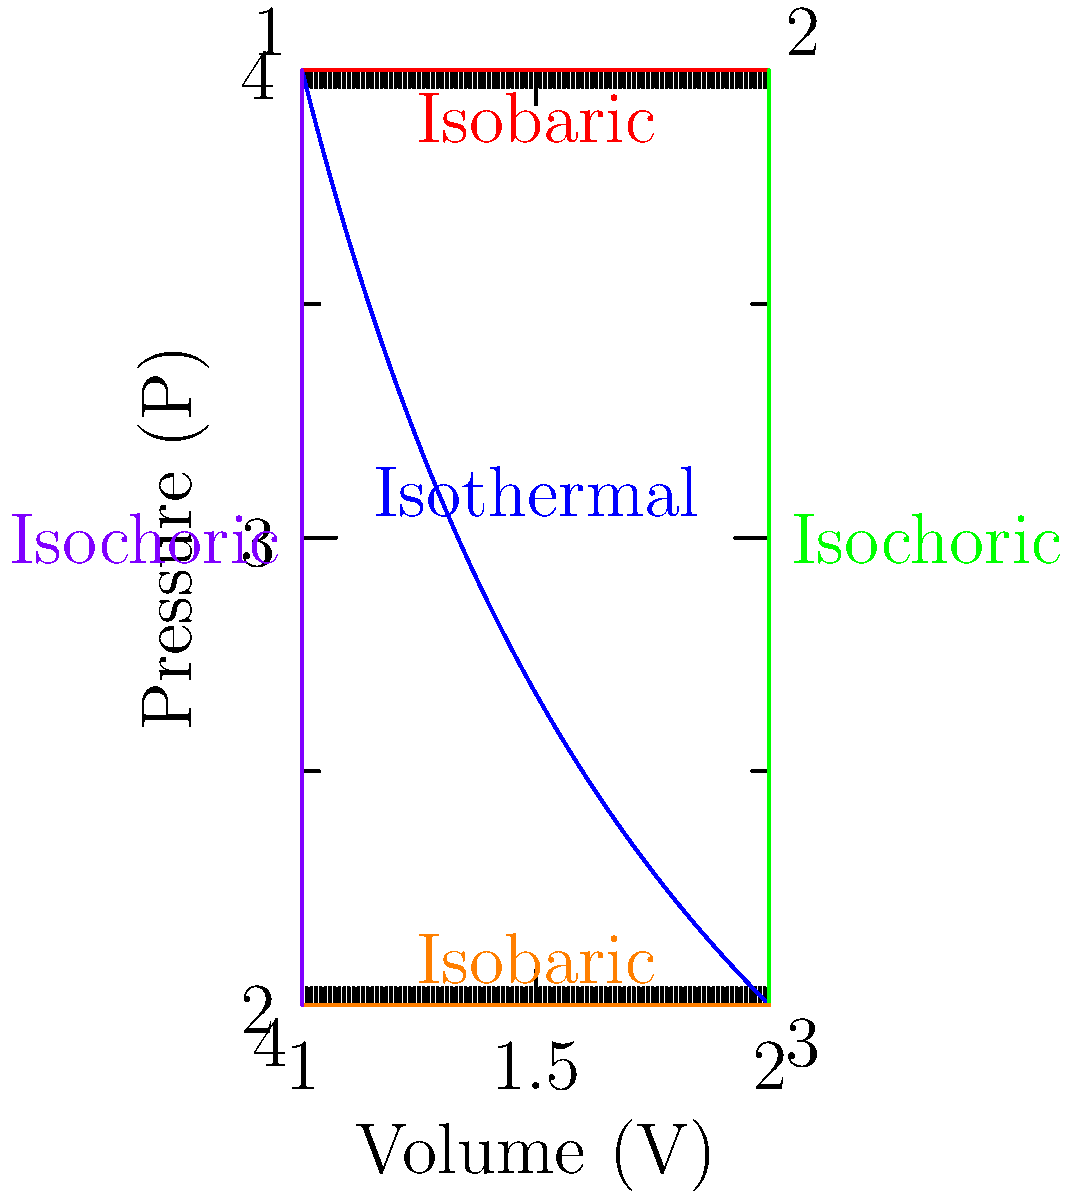As an offensive coordinator looking to expand your knowledge, consider the pressure-volume (P-V) diagram of an ideal gas undergoing a thermodynamic cycle shown above. The cycle consists of four processes: isothermal expansion (1-2), isobaric expansion (2-3), isothermal compression (3-4), and isobaric compression (4-1). If the work done by the gas during the isothermal expansion (1-2) is 277 J, what is the temperature of the gas during this process? To solve this problem, let's follow these steps:

1) For an isothermal process of an ideal gas, we can use the equation:
   $$W = nRT \ln\frac{V_2}{V_1}$$
   where W is work done, n is the number of moles, R is the gas constant, T is temperature, and V_1 and V_2 are initial and final volumes.

2) We're given that W = 277 J for the isothermal expansion (1-2).

3) From the P-V diagram, we can see that V_2 = 2V_1.

4) Substituting these into our equation:
   $$277 = nRT \ln\frac{2V_1}{V_1} = nRT \ln 2$$

5) We can simplify ln 2 ≈ 0.693

6) Now our equation looks like:
   $$277 = 0.693nRT$$

7) We don't know n, but we can find nR from the ideal gas law:
   $$PV = nRT$$
   At point 1: $$4V_1 = nRT$$

8) Substituting this into our work equation:
   $$277 = 0.693 \cdot 4V_1 \cdot \frac{T}{V_1} = 2.772T$$

9) Solving for T:
   $$T = \frac{277}{2.772} = 100 K$$
Answer: 100 K 